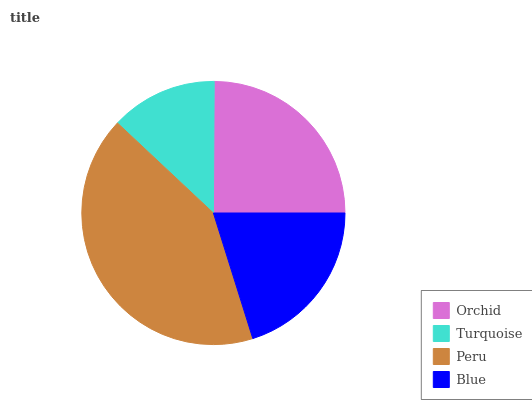Is Turquoise the minimum?
Answer yes or no. Yes. Is Peru the maximum?
Answer yes or no. Yes. Is Peru the minimum?
Answer yes or no. No. Is Turquoise the maximum?
Answer yes or no. No. Is Peru greater than Turquoise?
Answer yes or no. Yes. Is Turquoise less than Peru?
Answer yes or no. Yes. Is Turquoise greater than Peru?
Answer yes or no. No. Is Peru less than Turquoise?
Answer yes or no. No. Is Orchid the high median?
Answer yes or no. Yes. Is Blue the low median?
Answer yes or no. Yes. Is Blue the high median?
Answer yes or no. No. Is Turquoise the low median?
Answer yes or no. No. 